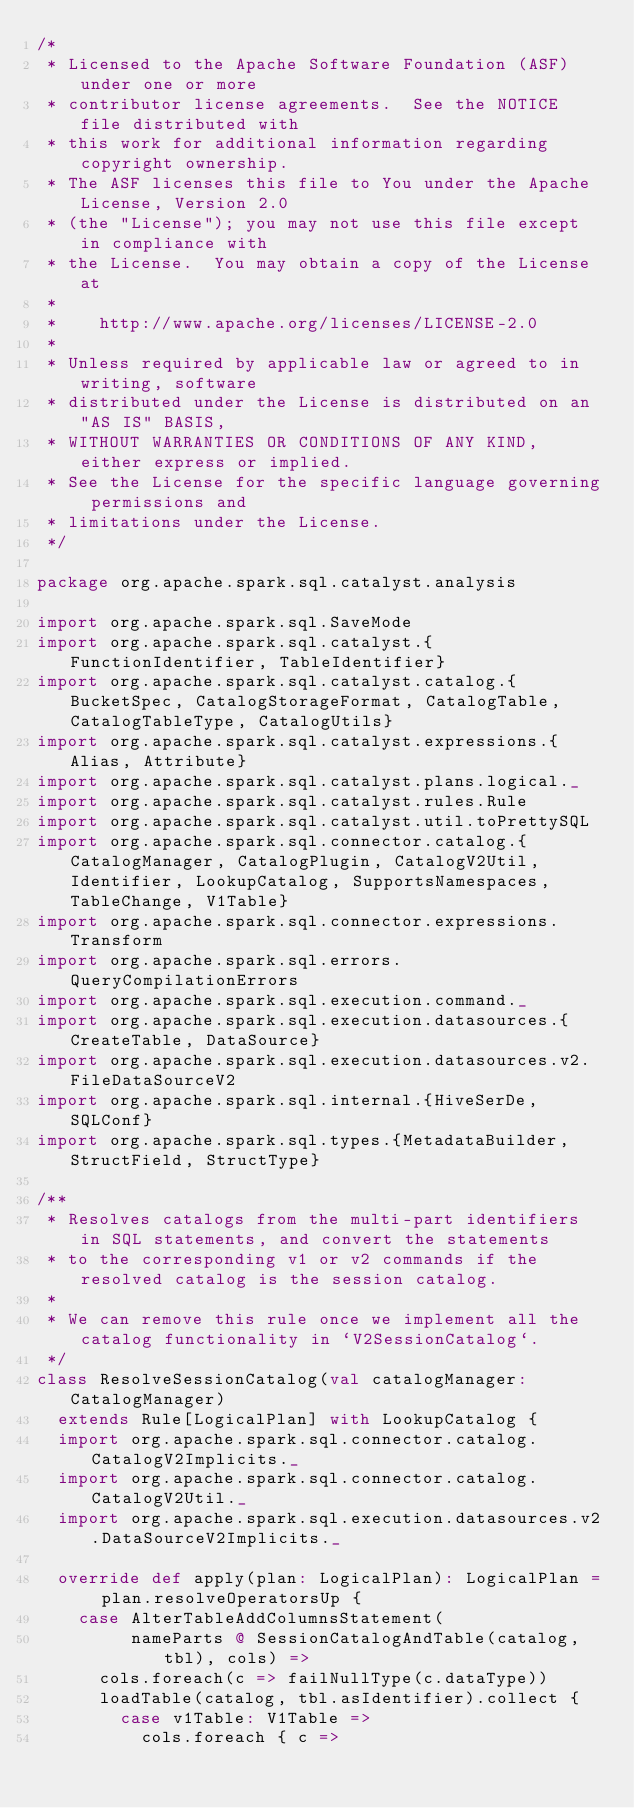Convert code to text. <code><loc_0><loc_0><loc_500><loc_500><_Scala_>/*
 * Licensed to the Apache Software Foundation (ASF) under one or more
 * contributor license agreements.  See the NOTICE file distributed with
 * this work for additional information regarding copyright ownership.
 * The ASF licenses this file to You under the Apache License, Version 2.0
 * (the "License"); you may not use this file except in compliance with
 * the License.  You may obtain a copy of the License at
 *
 *    http://www.apache.org/licenses/LICENSE-2.0
 *
 * Unless required by applicable law or agreed to in writing, software
 * distributed under the License is distributed on an "AS IS" BASIS,
 * WITHOUT WARRANTIES OR CONDITIONS OF ANY KIND, either express or implied.
 * See the License for the specific language governing permissions and
 * limitations under the License.
 */

package org.apache.spark.sql.catalyst.analysis

import org.apache.spark.sql.SaveMode
import org.apache.spark.sql.catalyst.{FunctionIdentifier, TableIdentifier}
import org.apache.spark.sql.catalyst.catalog.{BucketSpec, CatalogStorageFormat, CatalogTable, CatalogTableType, CatalogUtils}
import org.apache.spark.sql.catalyst.expressions.{Alias, Attribute}
import org.apache.spark.sql.catalyst.plans.logical._
import org.apache.spark.sql.catalyst.rules.Rule
import org.apache.spark.sql.catalyst.util.toPrettySQL
import org.apache.spark.sql.connector.catalog.{CatalogManager, CatalogPlugin, CatalogV2Util, Identifier, LookupCatalog, SupportsNamespaces, TableChange, V1Table}
import org.apache.spark.sql.connector.expressions.Transform
import org.apache.spark.sql.errors.QueryCompilationErrors
import org.apache.spark.sql.execution.command._
import org.apache.spark.sql.execution.datasources.{CreateTable, DataSource}
import org.apache.spark.sql.execution.datasources.v2.FileDataSourceV2
import org.apache.spark.sql.internal.{HiveSerDe, SQLConf}
import org.apache.spark.sql.types.{MetadataBuilder, StructField, StructType}

/**
 * Resolves catalogs from the multi-part identifiers in SQL statements, and convert the statements
 * to the corresponding v1 or v2 commands if the resolved catalog is the session catalog.
 *
 * We can remove this rule once we implement all the catalog functionality in `V2SessionCatalog`.
 */
class ResolveSessionCatalog(val catalogManager: CatalogManager)
  extends Rule[LogicalPlan] with LookupCatalog {
  import org.apache.spark.sql.connector.catalog.CatalogV2Implicits._
  import org.apache.spark.sql.connector.catalog.CatalogV2Util._
  import org.apache.spark.sql.execution.datasources.v2.DataSourceV2Implicits._

  override def apply(plan: LogicalPlan): LogicalPlan = plan.resolveOperatorsUp {
    case AlterTableAddColumnsStatement(
         nameParts @ SessionCatalogAndTable(catalog, tbl), cols) =>
      cols.foreach(c => failNullType(c.dataType))
      loadTable(catalog, tbl.asIdentifier).collect {
        case v1Table: V1Table =>
          cols.foreach { c =></code> 